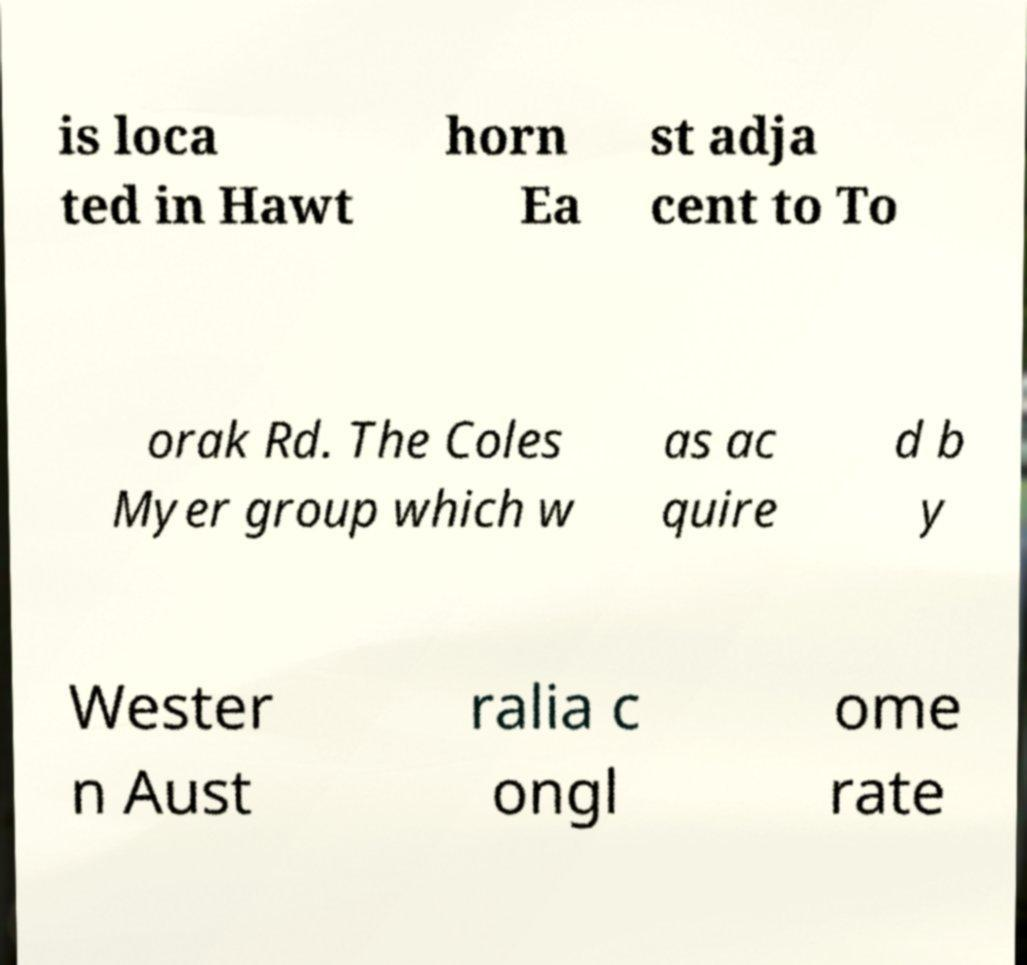Could you assist in decoding the text presented in this image and type it out clearly? is loca ted in Hawt horn Ea st adja cent to To orak Rd. The Coles Myer group which w as ac quire d b y Wester n Aust ralia c ongl ome rate 